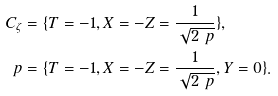<formula> <loc_0><loc_0><loc_500><loc_500>C _ { \zeta } & = \{ T = - 1 , X = - Z = \frac { 1 } { \sqrt { 2 \ p } } \} , \\ p & = \{ T = - 1 , X = - Z = \frac { 1 } { \sqrt { 2 \ p } } , Y = 0 \} .</formula> 